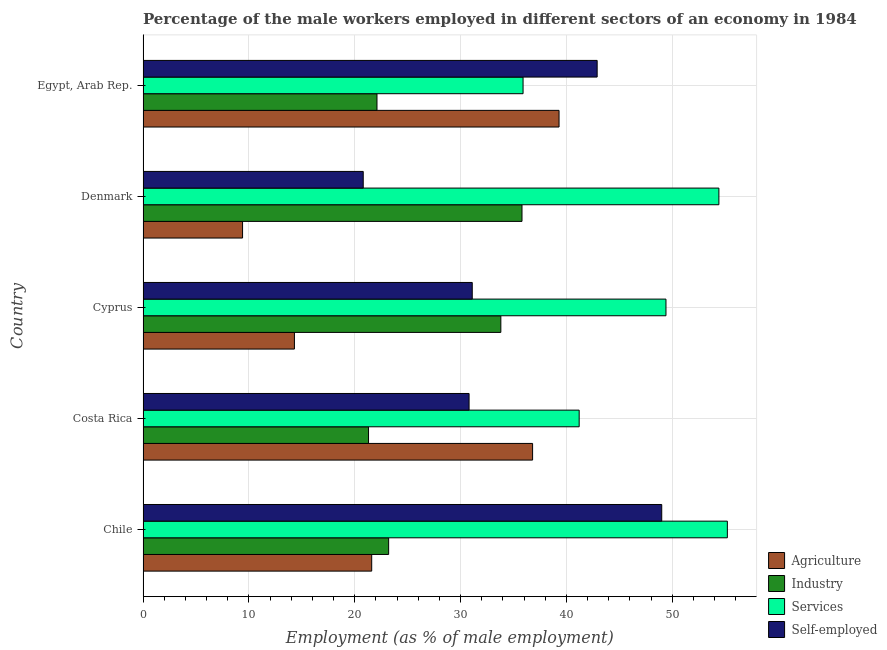How many different coloured bars are there?
Provide a short and direct response. 4. What is the label of the 5th group of bars from the top?
Offer a very short reply. Chile. In how many cases, is the number of bars for a given country not equal to the number of legend labels?
Your answer should be compact. 0. What is the percentage of male workers in industry in Costa Rica?
Your response must be concise. 21.3. Across all countries, what is the maximum percentage of male workers in agriculture?
Make the answer very short. 39.3. Across all countries, what is the minimum percentage of self employed male workers?
Give a very brief answer. 20.8. In which country was the percentage of male workers in agriculture minimum?
Ensure brevity in your answer.  Denmark. What is the total percentage of male workers in industry in the graph?
Provide a succinct answer. 136.2. What is the difference between the percentage of male workers in services in Costa Rica and that in Egypt, Arab Rep.?
Your answer should be very brief. 5.3. What is the difference between the percentage of male workers in services in Cyprus and the percentage of self employed male workers in Chile?
Give a very brief answer. 0.4. What is the average percentage of self employed male workers per country?
Provide a succinct answer. 34.92. What is the difference between the percentage of male workers in agriculture and percentage of male workers in industry in Chile?
Keep it short and to the point. -1.6. What is the ratio of the percentage of male workers in industry in Chile to that in Costa Rica?
Your answer should be very brief. 1.09. Is the percentage of male workers in agriculture in Chile less than that in Egypt, Arab Rep.?
Your answer should be compact. Yes. Is the difference between the percentage of self employed male workers in Cyprus and Egypt, Arab Rep. greater than the difference between the percentage of male workers in services in Cyprus and Egypt, Arab Rep.?
Your answer should be very brief. No. What is the difference between the highest and the second highest percentage of male workers in industry?
Offer a terse response. 2. What is the difference between the highest and the lowest percentage of male workers in agriculture?
Your answer should be very brief. 29.9. In how many countries, is the percentage of male workers in services greater than the average percentage of male workers in services taken over all countries?
Provide a succinct answer. 3. What does the 1st bar from the top in Egypt, Arab Rep. represents?
Keep it short and to the point. Self-employed. What does the 2nd bar from the bottom in Chile represents?
Your answer should be very brief. Industry. Is it the case that in every country, the sum of the percentage of male workers in agriculture and percentage of male workers in industry is greater than the percentage of male workers in services?
Your response must be concise. No. How many bars are there?
Provide a short and direct response. 20. Are all the bars in the graph horizontal?
Your answer should be very brief. Yes. How many countries are there in the graph?
Provide a short and direct response. 5. What is the difference between two consecutive major ticks on the X-axis?
Offer a very short reply. 10. Are the values on the major ticks of X-axis written in scientific E-notation?
Provide a succinct answer. No. Does the graph contain grids?
Your answer should be very brief. Yes. Where does the legend appear in the graph?
Make the answer very short. Bottom right. How many legend labels are there?
Your answer should be compact. 4. How are the legend labels stacked?
Offer a very short reply. Vertical. What is the title of the graph?
Ensure brevity in your answer.  Percentage of the male workers employed in different sectors of an economy in 1984. What is the label or title of the X-axis?
Offer a very short reply. Employment (as % of male employment). What is the label or title of the Y-axis?
Your response must be concise. Country. What is the Employment (as % of male employment) in Agriculture in Chile?
Provide a short and direct response. 21.6. What is the Employment (as % of male employment) in Industry in Chile?
Provide a succinct answer. 23.2. What is the Employment (as % of male employment) in Services in Chile?
Offer a very short reply. 55.2. What is the Employment (as % of male employment) of Agriculture in Costa Rica?
Your answer should be compact. 36.8. What is the Employment (as % of male employment) of Industry in Costa Rica?
Offer a very short reply. 21.3. What is the Employment (as % of male employment) in Services in Costa Rica?
Make the answer very short. 41.2. What is the Employment (as % of male employment) of Self-employed in Costa Rica?
Provide a succinct answer. 30.8. What is the Employment (as % of male employment) in Agriculture in Cyprus?
Provide a succinct answer. 14.3. What is the Employment (as % of male employment) in Industry in Cyprus?
Give a very brief answer. 33.8. What is the Employment (as % of male employment) in Services in Cyprus?
Provide a succinct answer. 49.4. What is the Employment (as % of male employment) in Self-employed in Cyprus?
Make the answer very short. 31.1. What is the Employment (as % of male employment) of Agriculture in Denmark?
Provide a short and direct response. 9.4. What is the Employment (as % of male employment) in Industry in Denmark?
Your answer should be compact. 35.8. What is the Employment (as % of male employment) in Services in Denmark?
Offer a terse response. 54.4. What is the Employment (as % of male employment) of Self-employed in Denmark?
Your answer should be very brief. 20.8. What is the Employment (as % of male employment) of Agriculture in Egypt, Arab Rep.?
Make the answer very short. 39.3. What is the Employment (as % of male employment) in Industry in Egypt, Arab Rep.?
Your answer should be very brief. 22.1. What is the Employment (as % of male employment) in Services in Egypt, Arab Rep.?
Provide a short and direct response. 35.9. What is the Employment (as % of male employment) in Self-employed in Egypt, Arab Rep.?
Offer a terse response. 42.9. Across all countries, what is the maximum Employment (as % of male employment) in Agriculture?
Offer a terse response. 39.3. Across all countries, what is the maximum Employment (as % of male employment) of Industry?
Your answer should be compact. 35.8. Across all countries, what is the maximum Employment (as % of male employment) in Services?
Give a very brief answer. 55.2. Across all countries, what is the minimum Employment (as % of male employment) of Agriculture?
Make the answer very short. 9.4. Across all countries, what is the minimum Employment (as % of male employment) in Industry?
Give a very brief answer. 21.3. Across all countries, what is the minimum Employment (as % of male employment) of Services?
Ensure brevity in your answer.  35.9. Across all countries, what is the minimum Employment (as % of male employment) in Self-employed?
Provide a succinct answer. 20.8. What is the total Employment (as % of male employment) of Agriculture in the graph?
Offer a very short reply. 121.4. What is the total Employment (as % of male employment) of Industry in the graph?
Provide a short and direct response. 136.2. What is the total Employment (as % of male employment) of Services in the graph?
Your response must be concise. 236.1. What is the total Employment (as % of male employment) in Self-employed in the graph?
Give a very brief answer. 174.6. What is the difference between the Employment (as % of male employment) in Agriculture in Chile and that in Costa Rica?
Your answer should be very brief. -15.2. What is the difference between the Employment (as % of male employment) of Industry in Chile and that in Costa Rica?
Offer a very short reply. 1.9. What is the difference between the Employment (as % of male employment) of Services in Chile and that in Cyprus?
Ensure brevity in your answer.  5.8. What is the difference between the Employment (as % of male employment) in Agriculture in Chile and that in Denmark?
Your response must be concise. 12.2. What is the difference between the Employment (as % of male employment) in Self-employed in Chile and that in Denmark?
Provide a succinct answer. 28.2. What is the difference between the Employment (as % of male employment) of Agriculture in Chile and that in Egypt, Arab Rep.?
Offer a very short reply. -17.7. What is the difference between the Employment (as % of male employment) of Industry in Chile and that in Egypt, Arab Rep.?
Keep it short and to the point. 1.1. What is the difference between the Employment (as % of male employment) in Services in Chile and that in Egypt, Arab Rep.?
Make the answer very short. 19.3. What is the difference between the Employment (as % of male employment) in Industry in Costa Rica and that in Cyprus?
Provide a succinct answer. -12.5. What is the difference between the Employment (as % of male employment) of Services in Costa Rica and that in Cyprus?
Provide a succinct answer. -8.2. What is the difference between the Employment (as % of male employment) of Self-employed in Costa Rica and that in Cyprus?
Make the answer very short. -0.3. What is the difference between the Employment (as % of male employment) in Agriculture in Costa Rica and that in Denmark?
Your answer should be very brief. 27.4. What is the difference between the Employment (as % of male employment) of Services in Costa Rica and that in Denmark?
Make the answer very short. -13.2. What is the difference between the Employment (as % of male employment) in Agriculture in Costa Rica and that in Egypt, Arab Rep.?
Ensure brevity in your answer.  -2.5. What is the difference between the Employment (as % of male employment) of Industry in Costa Rica and that in Egypt, Arab Rep.?
Give a very brief answer. -0.8. What is the difference between the Employment (as % of male employment) of Agriculture in Cyprus and that in Denmark?
Make the answer very short. 4.9. What is the difference between the Employment (as % of male employment) in Industry in Cyprus and that in Denmark?
Your response must be concise. -2. What is the difference between the Employment (as % of male employment) in Self-employed in Cyprus and that in Denmark?
Your answer should be compact. 10.3. What is the difference between the Employment (as % of male employment) of Agriculture in Cyprus and that in Egypt, Arab Rep.?
Provide a short and direct response. -25. What is the difference between the Employment (as % of male employment) of Industry in Cyprus and that in Egypt, Arab Rep.?
Provide a succinct answer. 11.7. What is the difference between the Employment (as % of male employment) in Services in Cyprus and that in Egypt, Arab Rep.?
Ensure brevity in your answer.  13.5. What is the difference between the Employment (as % of male employment) of Self-employed in Cyprus and that in Egypt, Arab Rep.?
Your answer should be very brief. -11.8. What is the difference between the Employment (as % of male employment) in Agriculture in Denmark and that in Egypt, Arab Rep.?
Offer a very short reply. -29.9. What is the difference between the Employment (as % of male employment) in Industry in Denmark and that in Egypt, Arab Rep.?
Make the answer very short. 13.7. What is the difference between the Employment (as % of male employment) in Services in Denmark and that in Egypt, Arab Rep.?
Ensure brevity in your answer.  18.5. What is the difference between the Employment (as % of male employment) of Self-employed in Denmark and that in Egypt, Arab Rep.?
Offer a terse response. -22.1. What is the difference between the Employment (as % of male employment) in Agriculture in Chile and the Employment (as % of male employment) in Industry in Costa Rica?
Your response must be concise. 0.3. What is the difference between the Employment (as % of male employment) of Agriculture in Chile and the Employment (as % of male employment) of Services in Costa Rica?
Provide a short and direct response. -19.6. What is the difference between the Employment (as % of male employment) in Agriculture in Chile and the Employment (as % of male employment) in Self-employed in Costa Rica?
Ensure brevity in your answer.  -9.2. What is the difference between the Employment (as % of male employment) of Industry in Chile and the Employment (as % of male employment) of Self-employed in Costa Rica?
Keep it short and to the point. -7.6. What is the difference between the Employment (as % of male employment) in Services in Chile and the Employment (as % of male employment) in Self-employed in Costa Rica?
Your response must be concise. 24.4. What is the difference between the Employment (as % of male employment) of Agriculture in Chile and the Employment (as % of male employment) of Services in Cyprus?
Keep it short and to the point. -27.8. What is the difference between the Employment (as % of male employment) in Agriculture in Chile and the Employment (as % of male employment) in Self-employed in Cyprus?
Keep it short and to the point. -9.5. What is the difference between the Employment (as % of male employment) in Industry in Chile and the Employment (as % of male employment) in Services in Cyprus?
Provide a short and direct response. -26.2. What is the difference between the Employment (as % of male employment) of Services in Chile and the Employment (as % of male employment) of Self-employed in Cyprus?
Provide a short and direct response. 24.1. What is the difference between the Employment (as % of male employment) of Agriculture in Chile and the Employment (as % of male employment) of Services in Denmark?
Provide a succinct answer. -32.8. What is the difference between the Employment (as % of male employment) in Industry in Chile and the Employment (as % of male employment) in Services in Denmark?
Your answer should be very brief. -31.2. What is the difference between the Employment (as % of male employment) of Industry in Chile and the Employment (as % of male employment) of Self-employed in Denmark?
Your answer should be compact. 2.4. What is the difference between the Employment (as % of male employment) in Services in Chile and the Employment (as % of male employment) in Self-employed in Denmark?
Make the answer very short. 34.4. What is the difference between the Employment (as % of male employment) in Agriculture in Chile and the Employment (as % of male employment) in Industry in Egypt, Arab Rep.?
Your answer should be compact. -0.5. What is the difference between the Employment (as % of male employment) in Agriculture in Chile and the Employment (as % of male employment) in Services in Egypt, Arab Rep.?
Offer a terse response. -14.3. What is the difference between the Employment (as % of male employment) of Agriculture in Chile and the Employment (as % of male employment) of Self-employed in Egypt, Arab Rep.?
Offer a very short reply. -21.3. What is the difference between the Employment (as % of male employment) in Industry in Chile and the Employment (as % of male employment) in Services in Egypt, Arab Rep.?
Offer a terse response. -12.7. What is the difference between the Employment (as % of male employment) of Industry in Chile and the Employment (as % of male employment) of Self-employed in Egypt, Arab Rep.?
Keep it short and to the point. -19.7. What is the difference between the Employment (as % of male employment) of Services in Chile and the Employment (as % of male employment) of Self-employed in Egypt, Arab Rep.?
Make the answer very short. 12.3. What is the difference between the Employment (as % of male employment) of Agriculture in Costa Rica and the Employment (as % of male employment) of Industry in Cyprus?
Your response must be concise. 3. What is the difference between the Employment (as % of male employment) of Industry in Costa Rica and the Employment (as % of male employment) of Services in Cyprus?
Provide a short and direct response. -28.1. What is the difference between the Employment (as % of male employment) in Services in Costa Rica and the Employment (as % of male employment) in Self-employed in Cyprus?
Keep it short and to the point. 10.1. What is the difference between the Employment (as % of male employment) of Agriculture in Costa Rica and the Employment (as % of male employment) of Industry in Denmark?
Keep it short and to the point. 1. What is the difference between the Employment (as % of male employment) in Agriculture in Costa Rica and the Employment (as % of male employment) in Services in Denmark?
Make the answer very short. -17.6. What is the difference between the Employment (as % of male employment) of Agriculture in Costa Rica and the Employment (as % of male employment) of Self-employed in Denmark?
Keep it short and to the point. 16. What is the difference between the Employment (as % of male employment) in Industry in Costa Rica and the Employment (as % of male employment) in Services in Denmark?
Your answer should be compact. -33.1. What is the difference between the Employment (as % of male employment) of Services in Costa Rica and the Employment (as % of male employment) of Self-employed in Denmark?
Offer a very short reply. 20.4. What is the difference between the Employment (as % of male employment) of Agriculture in Costa Rica and the Employment (as % of male employment) of Self-employed in Egypt, Arab Rep.?
Give a very brief answer. -6.1. What is the difference between the Employment (as % of male employment) in Industry in Costa Rica and the Employment (as % of male employment) in Services in Egypt, Arab Rep.?
Make the answer very short. -14.6. What is the difference between the Employment (as % of male employment) in Industry in Costa Rica and the Employment (as % of male employment) in Self-employed in Egypt, Arab Rep.?
Your answer should be compact. -21.6. What is the difference between the Employment (as % of male employment) of Services in Costa Rica and the Employment (as % of male employment) of Self-employed in Egypt, Arab Rep.?
Make the answer very short. -1.7. What is the difference between the Employment (as % of male employment) in Agriculture in Cyprus and the Employment (as % of male employment) in Industry in Denmark?
Keep it short and to the point. -21.5. What is the difference between the Employment (as % of male employment) in Agriculture in Cyprus and the Employment (as % of male employment) in Services in Denmark?
Provide a succinct answer. -40.1. What is the difference between the Employment (as % of male employment) of Agriculture in Cyprus and the Employment (as % of male employment) of Self-employed in Denmark?
Provide a short and direct response. -6.5. What is the difference between the Employment (as % of male employment) in Industry in Cyprus and the Employment (as % of male employment) in Services in Denmark?
Your answer should be very brief. -20.6. What is the difference between the Employment (as % of male employment) in Industry in Cyprus and the Employment (as % of male employment) in Self-employed in Denmark?
Keep it short and to the point. 13. What is the difference between the Employment (as % of male employment) of Services in Cyprus and the Employment (as % of male employment) of Self-employed in Denmark?
Your answer should be compact. 28.6. What is the difference between the Employment (as % of male employment) of Agriculture in Cyprus and the Employment (as % of male employment) of Industry in Egypt, Arab Rep.?
Give a very brief answer. -7.8. What is the difference between the Employment (as % of male employment) in Agriculture in Cyprus and the Employment (as % of male employment) in Services in Egypt, Arab Rep.?
Offer a terse response. -21.6. What is the difference between the Employment (as % of male employment) of Agriculture in Cyprus and the Employment (as % of male employment) of Self-employed in Egypt, Arab Rep.?
Your answer should be compact. -28.6. What is the difference between the Employment (as % of male employment) in Services in Cyprus and the Employment (as % of male employment) in Self-employed in Egypt, Arab Rep.?
Provide a succinct answer. 6.5. What is the difference between the Employment (as % of male employment) of Agriculture in Denmark and the Employment (as % of male employment) of Services in Egypt, Arab Rep.?
Keep it short and to the point. -26.5. What is the difference between the Employment (as % of male employment) of Agriculture in Denmark and the Employment (as % of male employment) of Self-employed in Egypt, Arab Rep.?
Your answer should be very brief. -33.5. What is the difference between the Employment (as % of male employment) of Industry in Denmark and the Employment (as % of male employment) of Self-employed in Egypt, Arab Rep.?
Your answer should be very brief. -7.1. What is the difference between the Employment (as % of male employment) in Services in Denmark and the Employment (as % of male employment) in Self-employed in Egypt, Arab Rep.?
Make the answer very short. 11.5. What is the average Employment (as % of male employment) of Agriculture per country?
Provide a succinct answer. 24.28. What is the average Employment (as % of male employment) of Industry per country?
Ensure brevity in your answer.  27.24. What is the average Employment (as % of male employment) of Services per country?
Provide a succinct answer. 47.22. What is the average Employment (as % of male employment) in Self-employed per country?
Ensure brevity in your answer.  34.92. What is the difference between the Employment (as % of male employment) of Agriculture and Employment (as % of male employment) of Industry in Chile?
Make the answer very short. -1.6. What is the difference between the Employment (as % of male employment) in Agriculture and Employment (as % of male employment) in Services in Chile?
Make the answer very short. -33.6. What is the difference between the Employment (as % of male employment) in Agriculture and Employment (as % of male employment) in Self-employed in Chile?
Your answer should be very brief. -27.4. What is the difference between the Employment (as % of male employment) in Industry and Employment (as % of male employment) in Services in Chile?
Make the answer very short. -32. What is the difference between the Employment (as % of male employment) in Industry and Employment (as % of male employment) in Self-employed in Chile?
Your answer should be compact. -25.8. What is the difference between the Employment (as % of male employment) of Agriculture and Employment (as % of male employment) of Services in Costa Rica?
Keep it short and to the point. -4.4. What is the difference between the Employment (as % of male employment) in Agriculture and Employment (as % of male employment) in Self-employed in Costa Rica?
Offer a very short reply. 6. What is the difference between the Employment (as % of male employment) of Industry and Employment (as % of male employment) of Services in Costa Rica?
Provide a short and direct response. -19.9. What is the difference between the Employment (as % of male employment) in Industry and Employment (as % of male employment) in Self-employed in Costa Rica?
Keep it short and to the point. -9.5. What is the difference between the Employment (as % of male employment) in Services and Employment (as % of male employment) in Self-employed in Costa Rica?
Your answer should be compact. 10.4. What is the difference between the Employment (as % of male employment) in Agriculture and Employment (as % of male employment) in Industry in Cyprus?
Ensure brevity in your answer.  -19.5. What is the difference between the Employment (as % of male employment) of Agriculture and Employment (as % of male employment) of Services in Cyprus?
Keep it short and to the point. -35.1. What is the difference between the Employment (as % of male employment) in Agriculture and Employment (as % of male employment) in Self-employed in Cyprus?
Your answer should be very brief. -16.8. What is the difference between the Employment (as % of male employment) of Industry and Employment (as % of male employment) of Services in Cyprus?
Offer a very short reply. -15.6. What is the difference between the Employment (as % of male employment) of Services and Employment (as % of male employment) of Self-employed in Cyprus?
Offer a very short reply. 18.3. What is the difference between the Employment (as % of male employment) in Agriculture and Employment (as % of male employment) in Industry in Denmark?
Keep it short and to the point. -26.4. What is the difference between the Employment (as % of male employment) of Agriculture and Employment (as % of male employment) of Services in Denmark?
Your answer should be very brief. -45. What is the difference between the Employment (as % of male employment) of Agriculture and Employment (as % of male employment) of Self-employed in Denmark?
Your answer should be very brief. -11.4. What is the difference between the Employment (as % of male employment) in Industry and Employment (as % of male employment) in Services in Denmark?
Offer a very short reply. -18.6. What is the difference between the Employment (as % of male employment) in Industry and Employment (as % of male employment) in Self-employed in Denmark?
Provide a short and direct response. 15. What is the difference between the Employment (as % of male employment) of Services and Employment (as % of male employment) of Self-employed in Denmark?
Offer a very short reply. 33.6. What is the difference between the Employment (as % of male employment) of Agriculture and Employment (as % of male employment) of Self-employed in Egypt, Arab Rep.?
Keep it short and to the point. -3.6. What is the difference between the Employment (as % of male employment) in Industry and Employment (as % of male employment) in Self-employed in Egypt, Arab Rep.?
Keep it short and to the point. -20.8. What is the ratio of the Employment (as % of male employment) in Agriculture in Chile to that in Costa Rica?
Give a very brief answer. 0.59. What is the ratio of the Employment (as % of male employment) of Industry in Chile to that in Costa Rica?
Give a very brief answer. 1.09. What is the ratio of the Employment (as % of male employment) in Services in Chile to that in Costa Rica?
Provide a succinct answer. 1.34. What is the ratio of the Employment (as % of male employment) in Self-employed in Chile to that in Costa Rica?
Ensure brevity in your answer.  1.59. What is the ratio of the Employment (as % of male employment) of Agriculture in Chile to that in Cyprus?
Ensure brevity in your answer.  1.51. What is the ratio of the Employment (as % of male employment) in Industry in Chile to that in Cyprus?
Provide a succinct answer. 0.69. What is the ratio of the Employment (as % of male employment) in Services in Chile to that in Cyprus?
Provide a succinct answer. 1.12. What is the ratio of the Employment (as % of male employment) in Self-employed in Chile to that in Cyprus?
Give a very brief answer. 1.58. What is the ratio of the Employment (as % of male employment) of Agriculture in Chile to that in Denmark?
Give a very brief answer. 2.3. What is the ratio of the Employment (as % of male employment) of Industry in Chile to that in Denmark?
Provide a short and direct response. 0.65. What is the ratio of the Employment (as % of male employment) of Services in Chile to that in Denmark?
Offer a very short reply. 1.01. What is the ratio of the Employment (as % of male employment) of Self-employed in Chile to that in Denmark?
Offer a terse response. 2.36. What is the ratio of the Employment (as % of male employment) of Agriculture in Chile to that in Egypt, Arab Rep.?
Give a very brief answer. 0.55. What is the ratio of the Employment (as % of male employment) of Industry in Chile to that in Egypt, Arab Rep.?
Keep it short and to the point. 1.05. What is the ratio of the Employment (as % of male employment) in Services in Chile to that in Egypt, Arab Rep.?
Your response must be concise. 1.54. What is the ratio of the Employment (as % of male employment) in Self-employed in Chile to that in Egypt, Arab Rep.?
Your answer should be compact. 1.14. What is the ratio of the Employment (as % of male employment) of Agriculture in Costa Rica to that in Cyprus?
Give a very brief answer. 2.57. What is the ratio of the Employment (as % of male employment) in Industry in Costa Rica to that in Cyprus?
Provide a succinct answer. 0.63. What is the ratio of the Employment (as % of male employment) of Services in Costa Rica to that in Cyprus?
Make the answer very short. 0.83. What is the ratio of the Employment (as % of male employment) of Agriculture in Costa Rica to that in Denmark?
Ensure brevity in your answer.  3.91. What is the ratio of the Employment (as % of male employment) of Industry in Costa Rica to that in Denmark?
Ensure brevity in your answer.  0.59. What is the ratio of the Employment (as % of male employment) in Services in Costa Rica to that in Denmark?
Ensure brevity in your answer.  0.76. What is the ratio of the Employment (as % of male employment) in Self-employed in Costa Rica to that in Denmark?
Offer a terse response. 1.48. What is the ratio of the Employment (as % of male employment) of Agriculture in Costa Rica to that in Egypt, Arab Rep.?
Offer a very short reply. 0.94. What is the ratio of the Employment (as % of male employment) in Industry in Costa Rica to that in Egypt, Arab Rep.?
Provide a succinct answer. 0.96. What is the ratio of the Employment (as % of male employment) of Services in Costa Rica to that in Egypt, Arab Rep.?
Provide a succinct answer. 1.15. What is the ratio of the Employment (as % of male employment) in Self-employed in Costa Rica to that in Egypt, Arab Rep.?
Make the answer very short. 0.72. What is the ratio of the Employment (as % of male employment) of Agriculture in Cyprus to that in Denmark?
Make the answer very short. 1.52. What is the ratio of the Employment (as % of male employment) in Industry in Cyprus to that in Denmark?
Your answer should be compact. 0.94. What is the ratio of the Employment (as % of male employment) in Services in Cyprus to that in Denmark?
Provide a succinct answer. 0.91. What is the ratio of the Employment (as % of male employment) of Self-employed in Cyprus to that in Denmark?
Give a very brief answer. 1.5. What is the ratio of the Employment (as % of male employment) in Agriculture in Cyprus to that in Egypt, Arab Rep.?
Provide a short and direct response. 0.36. What is the ratio of the Employment (as % of male employment) of Industry in Cyprus to that in Egypt, Arab Rep.?
Your answer should be very brief. 1.53. What is the ratio of the Employment (as % of male employment) in Services in Cyprus to that in Egypt, Arab Rep.?
Your answer should be very brief. 1.38. What is the ratio of the Employment (as % of male employment) of Self-employed in Cyprus to that in Egypt, Arab Rep.?
Your answer should be very brief. 0.72. What is the ratio of the Employment (as % of male employment) of Agriculture in Denmark to that in Egypt, Arab Rep.?
Provide a short and direct response. 0.24. What is the ratio of the Employment (as % of male employment) in Industry in Denmark to that in Egypt, Arab Rep.?
Make the answer very short. 1.62. What is the ratio of the Employment (as % of male employment) of Services in Denmark to that in Egypt, Arab Rep.?
Provide a short and direct response. 1.52. What is the ratio of the Employment (as % of male employment) in Self-employed in Denmark to that in Egypt, Arab Rep.?
Offer a very short reply. 0.48. What is the difference between the highest and the second highest Employment (as % of male employment) in Services?
Give a very brief answer. 0.8. What is the difference between the highest and the second highest Employment (as % of male employment) of Self-employed?
Give a very brief answer. 6.1. What is the difference between the highest and the lowest Employment (as % of male employment) in Agriculture?
Ensure brevity in your answer.  29.9. What is the difference between the highest and the lowest Employment (as % of male employment) in Industry?
Provide a succinct answer. 14.5. What is the difference between the highest and the lowest Employment (as % of male employment) in Services?
Make the answer very short. 19.3. What is the difference between the highest and the lowest Employment (as % of male employment) of Self-employed?
Give a very brief answer. 28.2. 